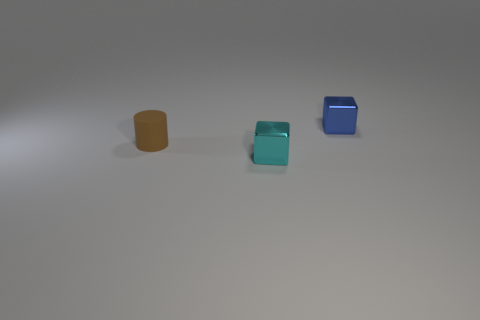Add 1 cyan metallic blocks. How many objects exist? 4 Subtract all cubes. How many objects are left? 1 Add 2 metal objects. How many metal objects exist? 4 Subtract 0 blue spheres. How many objects are left? 3 Subtract all tiny blocks. Subtract all big cyan metallic balls. How many objects are left? 1 Add 2 brown things. How many brown things are left? 3 